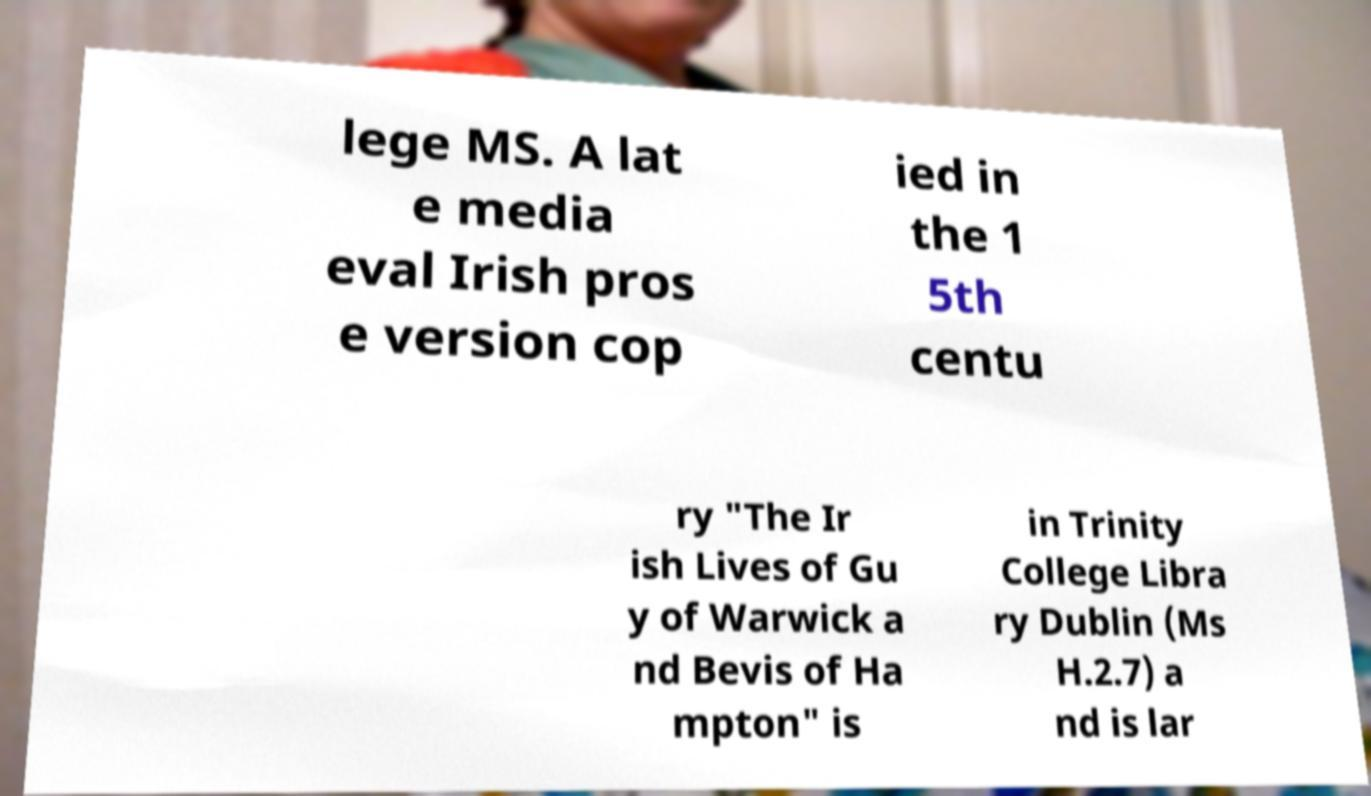I need the written content from this picture converted into text. Can you do that? lege MS. A lat e media eval Irish pros e version cop ied in the 1 5th centu ry "The Ir ish Lives of Gu y of Warwick a nd Bevis of Ha mpton" is in Trinity College Libra ry Dublin (Ms H.2.7) a nd is lar 